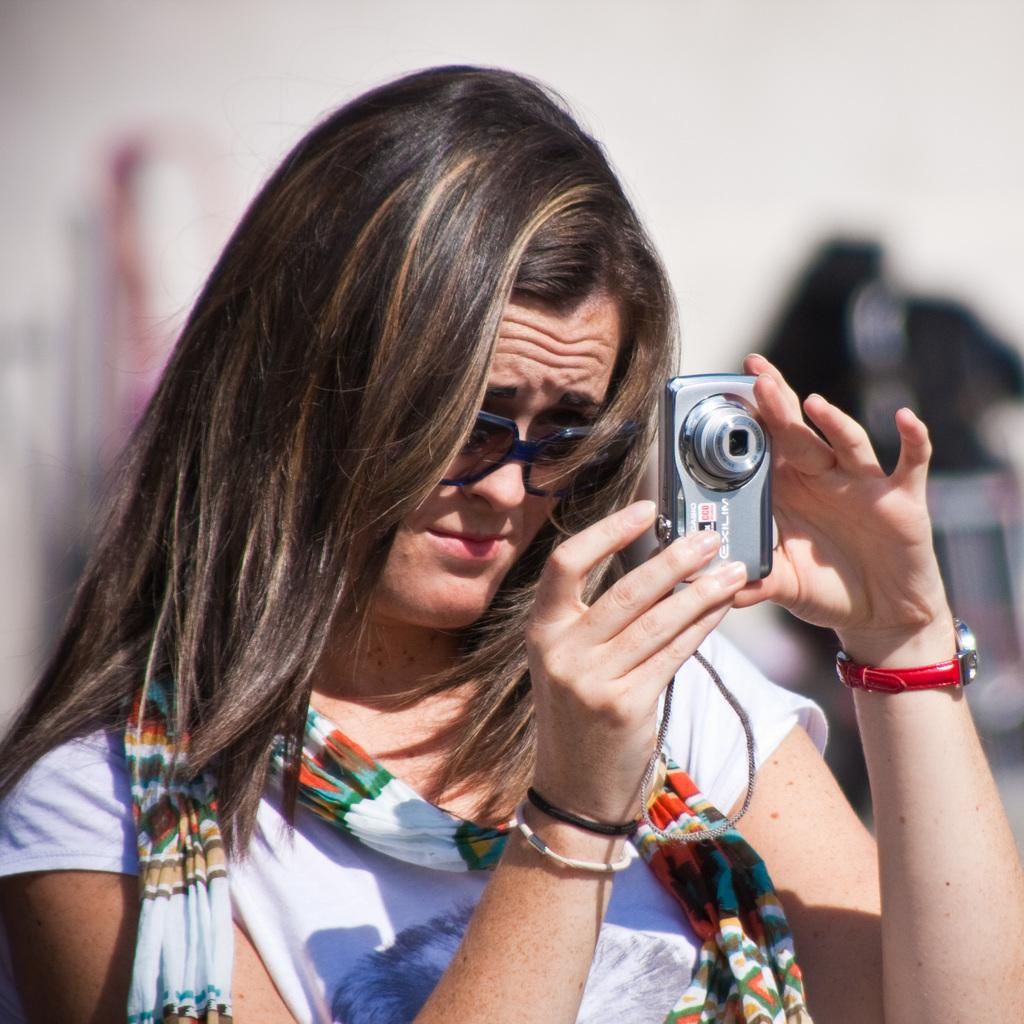Who is the main subject in the image? There is a woman in the image. What is the woman doing in the image? The woman is standing in the image. What object is the woman holding in her hand? The woman is holding a camera in her hand. What type of line can be seen in the image? There is no line present in the image. Where is the store located in the image? There is no store present in the image. 